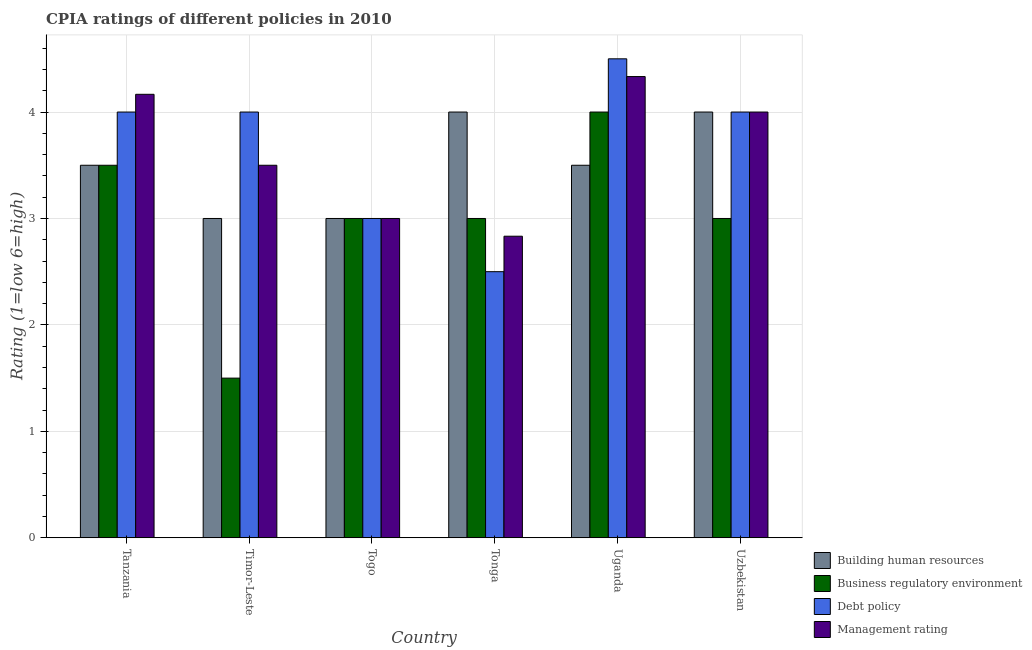Are the number of bars per tick equal to the number of legend labels?
Your answer should be compact. Yes. Are the number of bars on each tick of the X-axis equal?
Your response must be concise. Yes. How many bars are there on the 2nd tick from the left?
Offer a very short reply. 4. What is the label of the 5th group of bars from the left?
Your answer should be compact. Uganda. In how many cases, is the number of bars for a given country not equal to the number of legend labels?
Ensure brevity in your answer.  0. Across all countries, what is the maximum cpia rating of debt policy?
Your response must be concise. 4.5. In which country was the cpia rating of debt policy maximum?
Provide a succinct answer. Uganda. In which country was the cpia rating of business regulatory environment minimum?
Provide a succinct answer. Timor-Leste. What is the total cpia rating of management in the graph?
Make the answer very short. 21.83. What is the difference between the cpia rating of management in Tanzania and that in Tonga?
Your response must be concise. 1.33. What is the average cpia rating of debt policy per country?
Provide a succinct answer. 3.67. What is the difference between the cpia rating of building human resources and cpia rating of debt policy in Timor-Leste?
Provide a short and direct response. -1. In how many countries, is the cpia rating of building human resources greater than 3.8 ?
Ensure brevity in your answer.  2. What is the ratio of the cpia rating of management in Togo to that in Tonga?
Your response must be concise. 1.06. Is the cpia rating of building human resources in Tonga less than that in Uganda?
Keep it short and to the point. No. Is the difference between the cpia rating of debt policy in Togo and Uganda greater than the difference between the cpia rating of management in Togo and Uganda?
Keep it short and to the point. No. What is the difference between the highest and the lowest cpia rating of management?
Keep it short and to the point. 1.5. In how many countries, is the cpia rating of business regulatory environment greater than the average cpia rating of business regulatory environment taken over all countries?
Give a very brief answer. 2. Is the sum of the cpia rating of management in Tonga and Uzbekistan greater than the maximum cpia rating of building human resources across all countries?
Your answer should be very brief. Yes. Is it the case that in every country, the sum of the cpia rating of building human resources and cpia rating of debt policy is greater than the sum of cpia rating of management and cpia rating of business regulatory environment?
Provide a succinct answer. No. What does the 1st bar from the left in Uzbekistan represents?
Offer a very short reply. Building human resources. What does the 4th bar from the right in Uzbekistan represents?
Ensure brevity in your answer.  Building human resources. How many countries are there in the graph?
Provide a succinct answer. 6. What is the difference between two consecutive major ticks on the Y-axis?
Provide a short and direct response. 1. Are the values on the major ticks of Y-axis written in scientific E-notation?
Offer a terse response. No. Does the graph contain any zero values?
Your response must be concise. No. How are the legend labels stacked?
Provide a succinct answer. Vertical. What is the title of the graph?
Make the answer very short. CPIA ratings of different policies in 2010. Does "Social equity" appear as one of the legend labels in the graph?
Make the answer very short. No. What is the Rating (1=low 6=high) in Building human resources in Tanzania?
Offer a terse response. 3.5. What is the Rating (1=low 6=high) of Business regulatory environment in Tanzania?
Your answer should be compact. 3.5. What is the Rating (1=low 6=high) in Management rating in Tanzania?
Your response must be concise. 4.17. What is the Rating (1=low 6=high) in Building human resources in Timor-Leste?
Make the answer very short. 3. What is the Rating (1=low 6=high) in Business regulatory environment in Timor-Leste?
Give a very brief answer. 1.5. What is the Rating (1=low 6=high) in Management rating in Timor-Leste?
Your response must be concise. 3.5. What is the Rating (1=low 6=high) in Building human resources in Togo?
Provide a short and direct response. 3. What is the Rating (1=low 6=high) in Building human resources in Tonga?
Offer a very short reply. 4. What is the Rating (1=low 6=high) of Business regulatory environment in Tonga?
Your response must be concise. 3. What is the Rating (1=low 6=high) in Management rating in Tonga?
Keep it short and to the point. 2.83. What is the Rating (1=low 6=high) of Building human resources in Uganda?
Offer a very short reply. 3.5. What is the Rating (1=low 6=high) of Business regulatory environment in Uganda?
Ensure brevity in your answer.  4. What is the Rating (1=low 6=high) of Debt policy in Uganda?
Provide a short and direct response. 4.5. What is the Rating (1=low 6=high) in Management rating in Uganda?
Make the answer very short. 4.33. What is the Rating (1=low 6=high) in Building human resources in Uzbekistan?
Make the answer very short. 4. What is the Rating (1=low 6=high) of Business regulatory environment in Uzbekistan?
Offer a very short reply. 3. Across all countries, what is the maximum Rating (1=low 6=high) of Management rating?
Offer a terse response. 4.33. Across all countries, what is the minimum Rating (1=low 6=high) in Building human resources?
Keep it short and to the point. 3. Across all countries, what is the minimum Rating (1=low 6=high) of Business regulatory environment?
Give a very brief answer. 1.5. Across all countries, what is the minimum Rating (1=low 6=high) of Management rating?
Keep it short and to the point. 2.83. What is the total Rating (1=low 6=high) in Building human resources in the graph?
Make the answer very short. 21. What is the total Rating (1=low 6=high) in Management rating in the graph?
Provide a succinct answer. 21.83. What is the difference between the Rating (1=low 6=high) of Business regulatory environment in Tanzania and that in Timor-Leste?
Your answer should be very brief. 2. What is the difference between the Rating (1=low 6=high) in Debt policy in Tanzania and that in Timor-Leste?
Offer a terse response. 0. What is the difference between the Rating (1=low 6=high) of Management rating in Tanzania and that in Togo?
Give a very brief answer. 1.17. What is the difference between the Rating (1=low 6=high) in Building human resources in Tanzania and that in Uganda?
Give a very brief answer. 0. What is the difference between the Rating (1=low 6=high) in Debt policy in Tanzania and that in Uganda?
Provide a short and direct response. -0.5. What is the difference between the Rating (1=low 6=high) in Building human resources in Tanzania and that in Uzbekistan?
Your answer should be very brief. -0.5. What is the difference between the Rating (1=low 6=high) in Debt policy in Tanzania and that in Uzbekistan?
Give a very brief answer. 0. What is the difference between the Rating (1=low 6=high) in Building human resources in Timor-Leste and that in Tonga?
Make the answer very short. -1. What is the difference between the Rating (1=low 6=high) of Debt policy in Timor-Leste and that in Tonga?
Make the answer very short. 1.5. What is the difference between the Rating (1=low 6=high) of Debt policy in Timor-Leste and that in Uganda?
Make the answer very short. -0.5. What is the difference between the Rating (1=low 6=high) of Building human resources in Timor-Leste and that in Uzbekistan?
Provide a short and direct response. -1. What is the difference between the Rating (1=low 6=high) of Business regulatory environment in Timor-Leste and that in Uzbekistan?
Give a very brief answer. -1.5. What is the difference between the Rating (1=low 6=high) of Debt policy in Togo and that in Tonga?
Keep it short and to the point. 0.5. What is the difference between the Rating (1=low 6=high) in Management rating in Togo and that in Tonga?
Ensure brevity in your answer.  0.17. What is the difference between the Rating (1=low 6=high) in Debt policy in Togo and that in Uganda?
Ensure brevity in your answer.  -1.5. What is the difference between the Rating (1=low 6=high) in Management rating in Togo and that in Uganda?
Offer a very short reply. -1.33. What is the difference between the Rating (1=low 6=high) of Business regulatory environment in Togo and that in Uzbekistan?
Your response must be concise. 0. What is the difference between the Rating (1=low 6=high) of Management rating in Togo and that in Uzbekistan?
Provide a succinct answer. -1. What is the difference between the Rating (1=low 6=high) in Business regulatory environment in Tonga and that in Uganda?
Provide a succinct answer. -1. What is the difference between the Rating (1=low 6=high) in Business regulatory environment in Tonga and that in Uzbekistan?
Keep it short and to the point. 0. What is the difference between the Rating (1=low 6=high) of Management rating in Tonga and that in Uzbekistan?
Your answer should be very brief. -1.17. What is the difference between the Rating (1=low 6=high) in Building human resources in Uganda and that in Uzbekistan?
Offer a very short reply. -0.5. What is the difference between the Rating (1=low 6=high) in Business regulatory environment in Tanzania and the Rating (1=low 6=high) in Debt policy in Timor-Leste?
Ensure brevity in your answer.  -0.5. What is the difference between the Rating (1=low 6=high) of Building human resources in Tanzania and the Rating (1=low 6=high) of Business regulatory environment in Togo?
Give a very brief answer. 0.5. What is the difference between the Rating (1=low 6=high) of Building human resources in Tanzania and the Rating (1=low 6=high) of Debt policy in Togo?
Give a very brief answer. 0.5. What is the difference between the Rating (1=low 6=high) in Business regulatory environment in Tanzania and the Rating (1=low 6=high) in Debt policy in Togo?
Offer a terse response. 0.5. What is the difference between the Rating (1=low 6=high) of Business regulatory environment in Tanzania and the Rating (1=low 6=high) of Management rating in Togo?
Give a very brief answer. 0.5. What is the difference between the Rating (1=low 6=high) in Building human resources in Tanzania and the Rating (1=low 6=high) in Debt policy in Tonga?
Your answer should be very brief. 1. What is the difference between the Rating (1=low 6=high) of Business regulatory environment in Tanzania and the Rating (1=low 6=high) of Debt policy in Tonga?
Provide a short and direct response. 1. What is the difference between the Rating (1=low 6=high) in Business regulatory environment in Tanzania and the Rating (1=low 6=high) in Management rating in Tonga?
Offer a terse response. 0.67. What is the difference between the Rating (1=low 6=high) in Building human resources in Tanzania and the Rating (1=low 6=high) in Management rating in Uganda?
Offer a very short reply. -0.83. What is the difference between the Rating (1=low 6=high) in Debt policy in Tanzania and the Rating (1=low 6=high) in Management rating in Uganda?
Your response must be concise. -0.33. What is the difference between the Rating (1=low 6=high) of Building human resources in Tanzania and the Rating (1=low 6=high) of Business regulatory environment in Uzbekistan?
Offer a very short reply. 0.5. What is the difference between the Rating (1=low 6=high) of Building human resources in Tanzania and the Rating (1=low 6=high) of Debt policy in Uzbekistan?
Your answer should be compact. -0.5. What is the difference between the Rating (1=low 6=high) of Business regulatory environment in Tanzania and the Rating (1=low 6=high) of Debt policy in Uzbekistan?
Make the answer very short. -0.5. What is the difference between the Rating (1=low 6=high) of Debt policy in Tanzania and the Rating (1=low 6=high) of Management rating in Uzbekistan?
Your answer should be very brief. 0. What is the difference between the Rating (1=low 6=high) in Building human resources in Timor-Leste and the Rating (1=low 6=high) in Business regulatory environment in Togo?
Make the answer very short. 0. What is the difference between the Rating (1=low 6=high) in Building human resources in Timor-Leste and the Rating (1=low 6=high) in Debt policy in Togo?
Offer a very short reply. 0. What is the difference between the Rating (1=low 6=high) of Building human resources in Timor-Leste and the Rating (1=low 6=high) of Management rating in Togo?
Keep it short and to the point. 0. What is the difference between the Rating (1=low 6=high) in Business regulatory environment in Timor-Leste and the Rating (1=low 6=high) in Debt policy in Togo?
Provide a succinct answer. -1.5. What is the difference between the Rating (1=low 6=high) in Business regulatory environment in Timor-Leste and the Rating (1=low 6=high) in Management rating in Togo?
Give a very brief answer. -1.5. What is the difference between the Rating (1=low 6=high) of Debt policy in Timor-Leste and the Rating (1=low 6=high) of Management rating in Togo?
Give a very brief answer. 1. What is the difference between the Rating (1=low 6=high) of Building human resources in Timor-Leste and the Rating (1=low 6=high) of Business regulatory environment in Tonga?
Give a very brief answer. 0. What is the difference between the Rating (1=low 6=high) of Building human resources in Timor-Leste and the Rating (1=low 6=high) of Debt policy in Tonga?
Your answer should be compact. 0.5. What is the difference between the Rating (1=low 6=high) of Building human resources in Timor-Leste and the Rating (1=low 6=high) of Management rating in Tonga?
Make the answer very short. 0.17. What is the difference between the Rating (1=low 6=high) of Business regulatory environment in Timor-Leste and the Rating (1=low 6=high) of Management rating in Tonga?
Make the answer very short. -1.33. What is the difference between the Rating (1=low 6=high) in Debt policy in Timor-Leste and the Rating (1=low 6=high) in Management rating in Tonga?
Give a very brief answer. 1.17. What is the difference between the Rating (1=low 6=high) in Building human resources in Timor-Leste and the Rating (1=low 6=high) in Management rating in Uganda?
Make the answer very short. -1.33. What is the difference between the Rating (1=low 6=high) of Business regulatory environment in Timor-Leste and the Rating (1=low 6=high) of Management rating in Uganda?
Your answer should be very brief. -2.83. What is the difference between the Rating (1=low 6=high) of Building human resources in Togo and the Rating (1=low 6=high) of Business regulatory environment in Tonga?
Ensure brevity in your answer.  0. What is the difference between the Rating (1=low 6=high) of Building human resources in Togo and the Rating (1=low 6=high) of Debt policy in Tonga?
Give a very brief answer. 0.5. What is the difference between the Rating (1=low 6=high) in Building human resources in Togo and the Rating (1=low 6=high) in Management rating in Tonga?
Provide a short and direct response. 0.17. What is the difference between the Rating (1=low 6=high) in Business regulatory environment in Togo and the Rating (1=low 6=high) in Management rating in Tonga?
Make the answer very short. 0.17. What is the difference between the Rating (1=low 6=high) of Building human resources in Togo and the Rating (1=low 6=high) of Business regulatory environment in Uganda?
Provide a short and direct response. -1. What is the difference between the Rating (1=low 6=high) in Building human resources in Togo and the Rating (1=low 6=high) in Debt policy in Uganda?
Keep it short and to the point. -1.5. What is the difference between the Rating (1=low 6=high) in Building human resources in Togo and the Rating (1=low 6=high) in Management rating in Uganda?
Offer a terse response. -1.33. What is the difference between the Rating (1=low 6=high) of Business regulatory environment in Togo and the Rating (1=low 6=high) of Debt policy in Uganda?
Your answer should be very brief. -1.5. What is the difference between the Rating (1=low 6=high) of Business regulatory environment in Togo and the Rating (1=low 6=high) of Management rating in Uganda?
Your answer should be very brief. -1.33. What is the difference between the Rating (1=low 6=high) in Debt policy in Togo and the Rating (1=low 6=high) in Management rating in Uganda?
Your answer should be very brief. -1.33. What is the difference between the Rating (1=low 6=high) of Building human resources in Togo and the Rating (1=low 6=high) of Debt policy in Uzbekistan?
Give a very brief answer. -1. What is the difference between the Rating (1=low 6=high) of Building human resources in Tonga and the Rating (1=low 6=high) of Management rating in Uganda?
Offer a very short reply. -0.33. What is the difference between the Rating (1=low 6=high) of Business regulatory environment in Tonga and the Rating (1=low 6=high) of Management rating in Uganda?
Provide a short and direct response. -1.33. What is the difference between the Rating (1=low 6=high) of Debt policy in Tonga and the Rating (1=low 6=high) of Management rating in Uganda?
Offer a very short reply. -1.83. What is the difference between the Rating (1=low 6=high) of Building human resources in Tonga and the Rating (1=low 6=high) of Business regulatory environment in Uzbekistan?
Keep it short and to the point. 1. What is the difference between the Rating (1=low 6=high) of Building human resources in Tonga and the Rating (1=low 6=high) of Debt policy in Uzbekistan?
Offer a terse response. 0. What is the difference between the Rating (1=low 6=high) of Building human resources in Tonga and the Rating (1=low 6=high) of Management rating in Uzbekistan?
Ensure brevity in your answer.  0. What is the difference between the Rating (1=low 6=high) in Business regulatory environment in Tonga and the Rating (1=low 6=high) in Management rating in Uzbekistan?
Offer a terse response. -1. What is the difference between the Rating (1=low 6=high) in Debt policy in Tonga and the Rating (1=low 6=high) in Management rating in Uzbekistan?
Your answer should be very brief. -1.5. What is the difference between the Rating (1=low 6=high) in Building human resources in Uganda and the Rating (1=low 6=high) in Debt policy in Uzbekistan?
Your answer should be very brief. -0.5. What is the difference between the Rating (1=low 6=high) of Business regulatory environment in Uganda and the Rating (1=low 6=high) of Debt policy in Uzbekistan?
Ensure brevity in your answer.  0. What is the difference between the Rating (1=low 6=high) in Business regulatory environment in Uganda and the Rating (1=low 6=high) in Management rating in Uzbekistan?
Keep it short and to the point. 0. What is the difference between the Rating (1=low 6=high) of Debt policy in Uganda and the Rating (1=low 6=high) of Management rating in Uzbekistan?
Offer a very short reply. 0.5. What is the average Rating (1=low 6=high) in Building human resources per country?
Your answer should be very brief. 3.5. What is the average Rating (1=low 6=high) of Business regulatory environment per country?
Provide a succinct answer. 3. What is the average Rating (1=low 6=high) in Debt policy per country?
Provide a succinct answer. 3.67. What is the average Rating (1=low 6=high) in Management rating per country?
Your answer should be compact. 3.64. What is the difference between the Rating (1=low 6=high) in Building human resources and Rating (1=low 6=high) in Business regulatory environment in Tanzania?
Provide a short and direct response. 0. What is the difference between the Rating (1=low 6=high) in Debt policy and Rating (1=low 6=high) in Management rating in Tanzania?
Make the answer very short. -0.17. What is the difference between the Rating (1=low 6=high) in Building human resources and Rating (1=low 6=high) in Business regulatory environment in Timor-Leste?
Give a very brief answer. 1.5. What is the difference between the Rating (1=low 6=high) of Building human resources and Rating (1=low 6=high) of Management rating in Timor-Leste?
Your answer should be very brief. -0.5. What is the difference between the Rating (1=low 6=high) of Business regulatory environment and Rating (1=low 6=high) of Debt policy in Timor-Leste?
Provide a succinct answer. -2.5. What is the difference between the Rating (1=low 6=high) in Building human resources and Rating (1=low 6=high) in Debt policy in Togo?
Offer a very short reply. 0. What is the difference between the Rating (1=low 6=high) of Building human resources and Rating (1=low 6=high) of Management rating in Togo?
Provide a succinct answer. 0. What is the difference between the Rating (1=low 6=high) of Debt policy and Rating (1=low 6=high) of Management rating in Togo?
Make the answer very short. 0. What is the difference between the Rating (1=low 6=high) of Building human resources and Rating (1=low 6=high) of Management rating in Tonga?
Provide a succinct answer. 1.17. What is the difference between the Rating (1=low 6=high) in Building human resources and Rating (1=low 6=high) in Business regulatory environment in Uganda?
Ensure brevity in your answer.  -0.5. What is the difference between the Rating (1=low 6=high) in Building human resources and Rating (1=low 6=high) in Debt policy in Uganda?
Provide a short and direct response. -1. What is the difference between the Rating (1=low 6=high) of Building human resources and Rating (1=low 6=high) of Management rating in Uganda?
Provide a succinct answer. -0.83. What is the difference between the Rating (1=low 6=high) in Business regulatory environment and Rating (1=low 6=high) in Debt policy in Uganda?
Ensure brevity in your answer.  -0.5. What is the difference between the Rating (1=low 6=high) in Debt policy and Rating (1=low 6=high) in Management rating in Uganda?
Your response must be concise. 0.17. What is the difference between the Rating (1=low 6=high) of Building human resources and Rating (1=low 6=high) of Debt policy in Uzbekistan?
Give a very brief answer. 0. What is the difference between the Rating (1=low 6=high) of Building human resources and Rating (1=low 6=high) of Management rating in Uzbekistan?
Ensure brevity in your answer.  0. What is the difference between the Rating (1=low 6=high) of Business regulatory environment and Rating (1=low 6=high) of Debt policy in Uzbekistan?
Your answer should be compact. -1. What is the difference between the Rating (1=low 6=high) of Debt policy and Rating (1=low 6=high) of Management rating in Uzbekistan?
Offer a very short reply. 0. What is the ratio of the Rating (1=low 6=high) in Business regulatory environment in Tanzania to that in Timor-Leste?
Provide a succinct answer. 2.33. What is the ratio of the Rating (1=low 6=high) in Debt policy in Tanzania to that in Timor-Leste?
Give a very brief answer. 1. What is the ratio of the Rating (1=low 6=high) in Management rating in Tanzania to that in Timor-Leste?
Offer a very short reply. 1.19. What is the ratio of the Rating (1=low 6=high) in Building human resources in Tanzania to that in Togo?
Ensure brevity in your answer.  1.17. What is the ratio of the Rating (1=low 6=high) of Business regulatory environment in Tanzania to that in Togo?
Provide a short and direct response. 1.17. What is the ratio of the Rating (1=low 6=high) in Management rating in Tanzania to that in Togo?
Provide a short and direct response. 1.39. What is the ratio of the Rating (1=low 6=high) of Building human resources in Tanzania to that in Tonga?
Provide a short and direct response. 0.88. What is the ratio of the Rating (1=low 6=high) in Debt policy in Tanzania to that in Tonga?
Give a very brief answer. 1.6. What is the ratio of the Rating (1=low 6=high) of Management rating in Tanzania to that in Tonga?
Keep it short and to the point. 1.47. What is the ratio of the Rating (1=low 6=high) of Building human resources in Tanzania to that in Uganda?
Offer a very short reply. 1. What is the ratio of the Rating (1=low 6=high) of Business regulatory environment in Tanzania to that in Uganda?
Ensure brevity in your answer.  0.88. What is the ratio of the Rating (1=low 6=high) of Management rating in Tanzania to that in Uganda?
Offer a terse response. 0.96. What is the ratio of the Rating (1=low 6=high) in Building human resources in Tanzania to that in Uzbekistan?
Your response must be concise. 0.88. What is the ratio of the Rating (1=low 6=high) in Business regulatory environment in Tanzania to that in Uzbekistan?
Give a very brief answer. 1.17. What is the ratio of the Rating (1=low 6=high) in Debt policy in Tanzania to that in Uzbekistan?
Offer a terse response. 1. What is the ratio of the Rating (1=low 6=high) in Management rating in Tanzania to that in Uzbekistan?
Offer a very short reply. 1.04. What is the ratio of the Rating (1=low 6=high) of Building human resources in Timor-Leste to that in Togo?
Provide a succinct answer. 1. What is the ratio of the Rating (1=low 6=high) in Business regulatory environment in Timor-Leste to that in Togo?
Give a very brief answer. 0.5. What is the ratio of the Rating (1=low 6=high) of Debt policy in Timor-Leste to that in Togo?
Offer a terse response. 1.33. What is the ratio of the Rating (1=low 6=high) in Building human resources in Timor-Leste to that in Tonga?
Your answer should be very brief. 0.75. What is the ratio of the Rating (1=low 6=high) of Debt policy in Timor-Leste to that in Tonga?
Provide a short and direct response. 1.6. What is the ratio of the Rating (1=low 6=high) in Management rating in Timor-Leste to that in Tonga?
Your response must be concise. 1.24. What is the ratio of the Rating (1=low 6=high) in Building human resources in Timor-Leste to that in Uganda?
Give a very brief answer. 0.86. What is the ratio of the Rating (1=low 6=high) in Management rating in Timor-Leste to that in Uganda?
Provide a short and direct response. 0.81. What is the ratio of the Rating (1=low 6=high) of Business regulatory environment in Timor-Leste to that in Uzbekistan?
Offer a terse response. 0.5. What is the ratio of the Rating (1=low 6=high) in Debt policy in Timor-Leste to that in Uzbekistan?
Your response must be concise. 1. What is the ratio of the Rating (1=low 6=high) of Management rating in Timor-Leste to that in Uzbekistan?
Offer a very short reply. 0.88. What is the ratio of the Rating (1=low 6=high) in Management rating in Togo to that in Tonga?
Offer a terse response. 1.06. What is the ratio of the Rating (1=low 6=high) in Business regulatory environment in Togo to that in Uganda?
Give a very brief answer. 0.75. What is the ratio of the Rating (1=low 6=high) of Debt policy in Togo to that in Uganda?
Your response must be concise. 0.67. What is the ratio of the Rating (1=low 6=high) of Management rating in Togo to that in Uganda?
Ensure brevity in your answer.  0.69. What is the ratio of the Rating (1=low 6=high) of Debt policy in Togo to that in Uzbekistan?
Provide a short and direct response. 0.75. What is the ratio of the Rating (1=low 6=high) of Building human resources in Tonga to that in Uganda?
Provide a short and direct response. 1.14. What is the ratio of the Rating (1=low 6=high) in Debt policy in Tonga to that in Uganda?
Provide a succinct answer. 0.56. What is the ratio of the Rating (1=low 6=high) of Management rating in Tonga to that in Uganda?
Keep it short and to the point. 0.65. What is the ratio of the Rating (1=low 6=high) in Business regulatory environment in Tonga to that in Uzbekistan?
Make the answer very short. 1. What is the ratio of the Rating (1=low 6=high) of Management rating in Tonga to that in Uzbekistan?
Provide a short and direct response. 0.71. What is the ratio of the Rating (1=low 6=high) in Building human resources in Uganda to that in Uzbekistan?
Ensure brevity in your answer.  0.88. What is the ratio of the Rating (1=low 6=high) in Business regulatory environment in Uganda to that in Uzbekistan?
Your answer should be very brief. 1.33. What is the ratio of the Rating (1=low 6=high) in Debt policy in Uganda to that in Uzbekistan?
Offer a very short reply. 1.12. What is the ratio of the Rating (1=low 6=high) in Management rating in Uganda to that in Uzbekistan?
Give a very brief answer. 1.08. What is the difference between the highest and the second highest Rating (1=low 6=high) in Building human resources?
Your answer should be very brief. 0. What is the difference between the highest and the second highest Rating (1=low 6=high) in Business regulatory environment?
Ensure brevity in your answer.  0.5. What is the difference between the highest and the second highest Rating (1=low 6=high) of Management rating?
Your answer should be compact. 0.17. What is the difference between the highest and the lowest Rating (1=low 6=high) in Business regulatory environment?
Your answer should be compact. 2.5. What is the difference between the highest and the lowest Rating (1=low 6=high) of Debt policy?
Ensure brevity in your answer.  2. What is the difference between the highest and the lowest Rating (1=low 6=high) of Management rating?
Your answer should be compact. 1.5. 